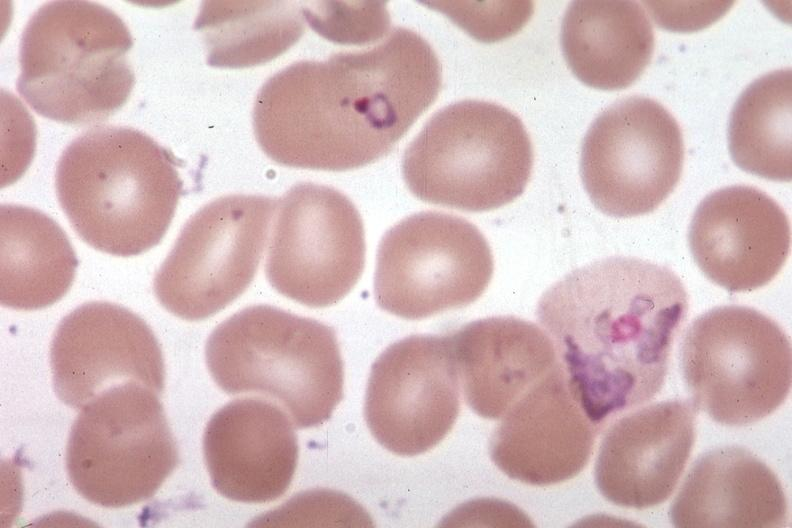what does this image show?
Answer the question using a single word or phrase. Oil wrights very good 